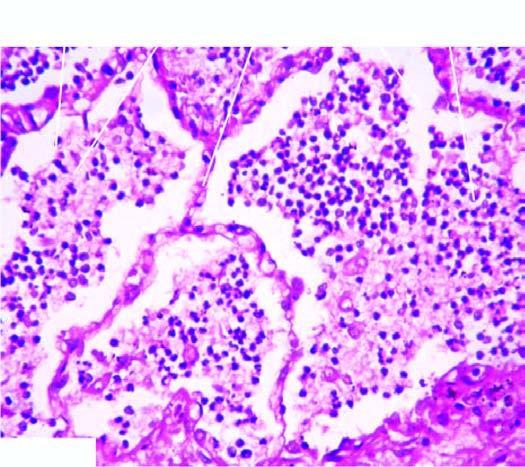s the infiltrate in the lumina composed of neutrophils and macrophages?
Answer the question using a single word or phrase. Yes 